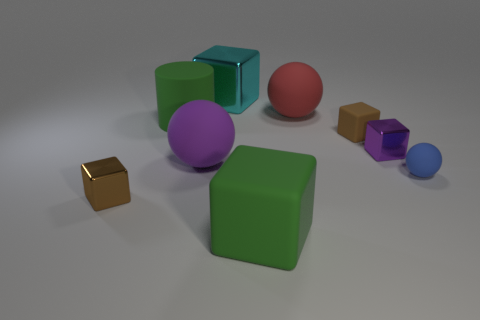Add 1 red spheres. How many objects exist? 10 Subtract all large balls. How many balls are left? 1 Subtract all green balls. How many brown blocks are left? 2 Subtract 3 cubes. How many cubes are left? 2 Subtract all red balls. How many balls are left? 2 Subtract all blocks. How many objects are left? 4 Subtract all yellow spheres. Subtract all brown cubes. How many spheres are left? 3 Subtract all green cylinders. Subtract all green rubber cylinders. How many objects are left? 7 Add 4 balls. How many balls are left? 7 Add 4 red balls. How many red balls exist? 5 